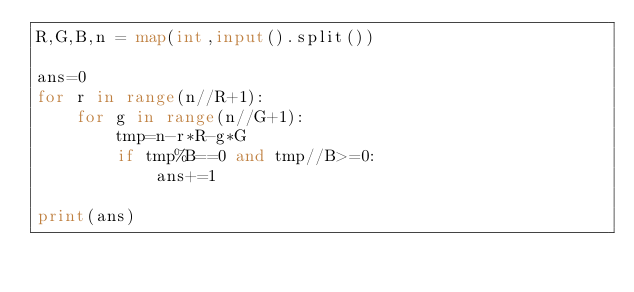Convert code to text. <code><loc_0><loc_0><loc_500><loc_500><_Python_>R,G,B,n = map(int,input().split())

ans=0
for r in range(n//R+1):
    for g in range(n//G+1):
        tmp=n-r*R-g*G
        if tmp%B==0 and tmp//B>=0:
            ans+=1

print(ans)
</code> 